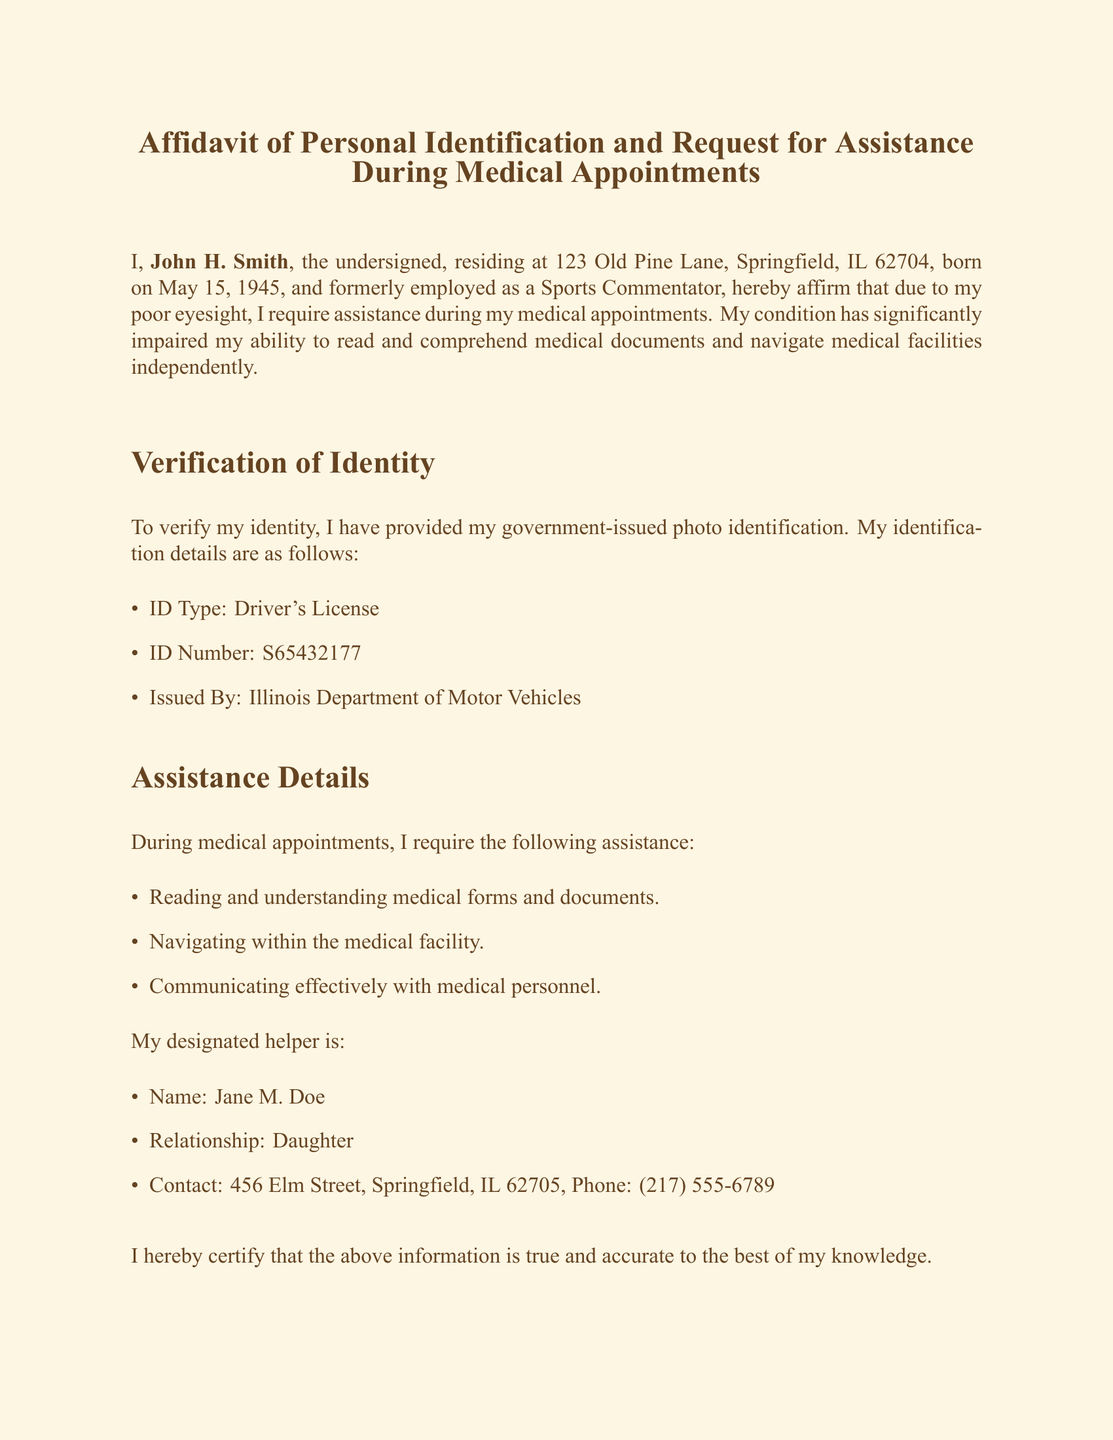What is the name of the person making the affidavit? The name is prominently stated at the beginning of the document, which is John H. Smith.
Answer: John H. Smith What is the ID type provided for identity verification? The document specifies the type of identification used for verification, which is detailed in the verification section.
Answer: Driver's License What is the ID number on the driver's license? The ID number is clearly stated under the identification details in the document.
Answer: S65432177 What is the date of birth of John H. Smith? The date of birth is mentioned alongside the name and address in the introductory paragraph.
Answer: May 15, 1945 Who is designated as John's helper during medical appointments? The helper's name is listed in the assistance details section of the affidavit.
Answer: Jane M. Doe What is the relationship of the designated helper to John H. Smith? This information is specified directly in the assistance section of the document.
Answer: Daughter What is the address of the witness? The witness's address is mentioned near their name in the document.
Answer: 789 Cedar Avenue, Springfield, IL 62706 What is the expiration date of the notary's commission? The expiration date is included in the notary section and is crucial for the validity of the affidavit.
Answer: December 31, 2025 How many items are listed under the assistance details? This can be counted from the listed assistance requirements outlined in the document.
Answer: Three 